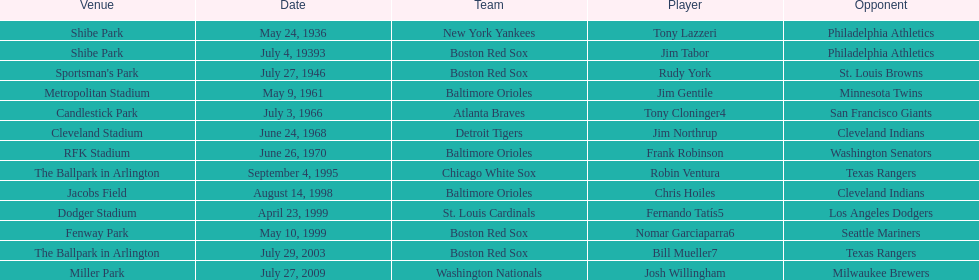On what date did the detroit tigers play the cleveland indians? June 24, 1968. 